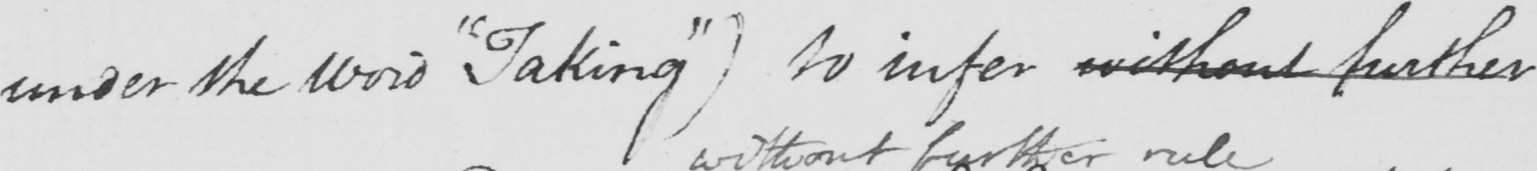What is written in this line of handwriting? under the word  " Taking "  )  to infer without further 